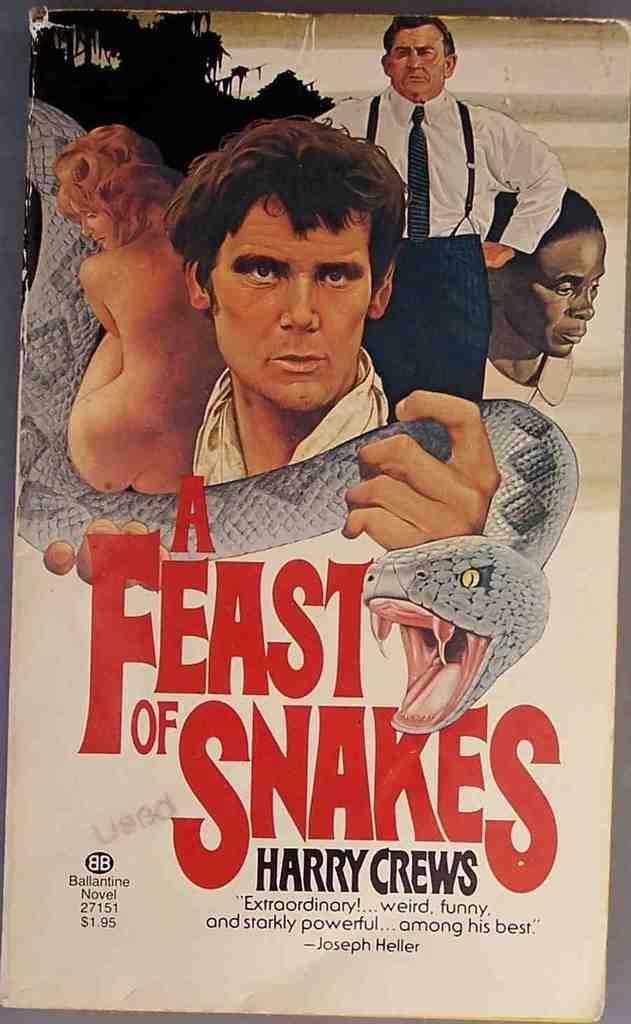<image>
Render a clear and concise summary of the photo. an old poster that says 'a feast of snakes' on it 